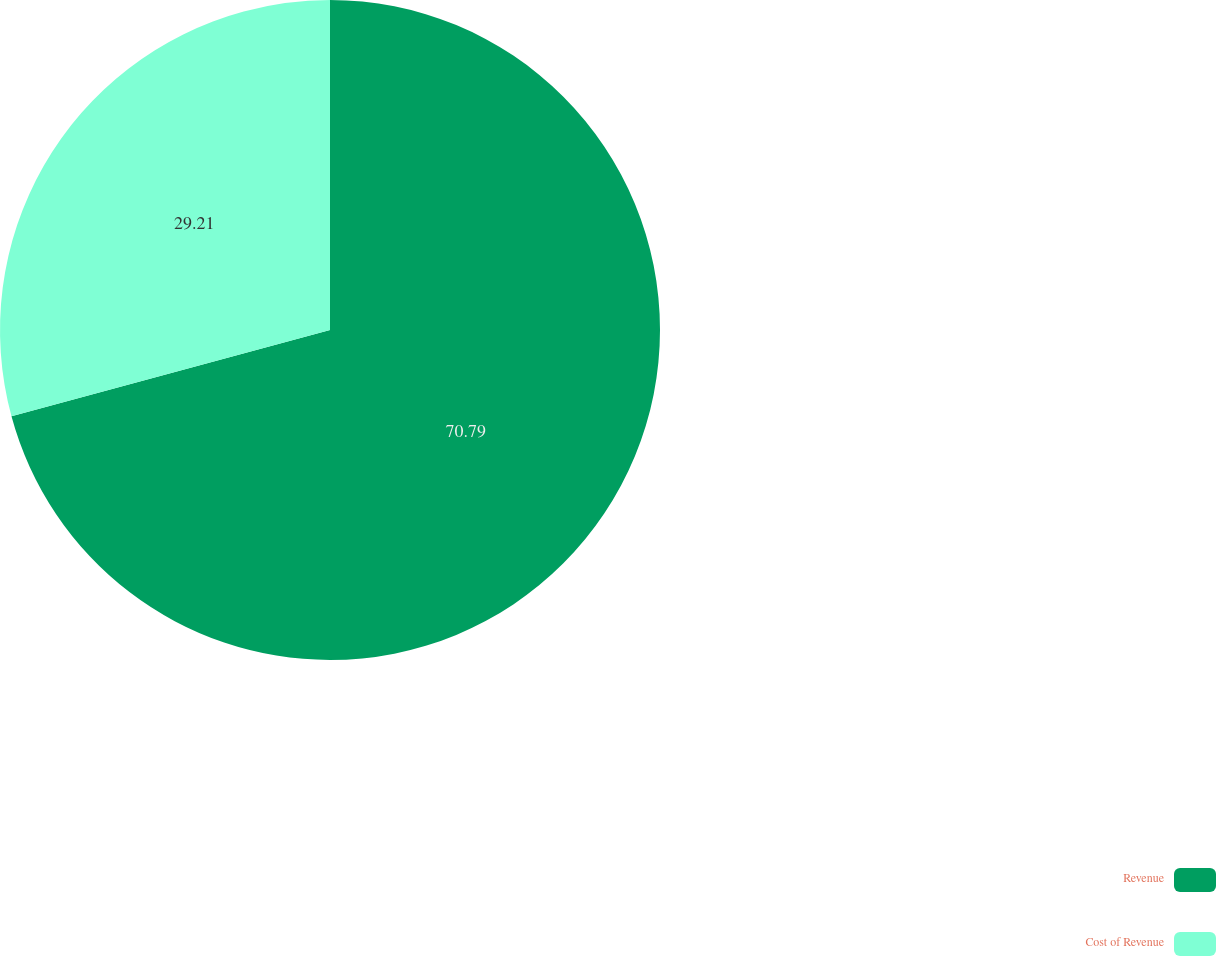Convert chart. <chart><loc_0><loc_0><loc_500><loc_500><pie_chart><fcel>Revenue<fcel>Cost of Revenue<nl><fcel>70.79%<fcel>29.21%<nl></chart> 